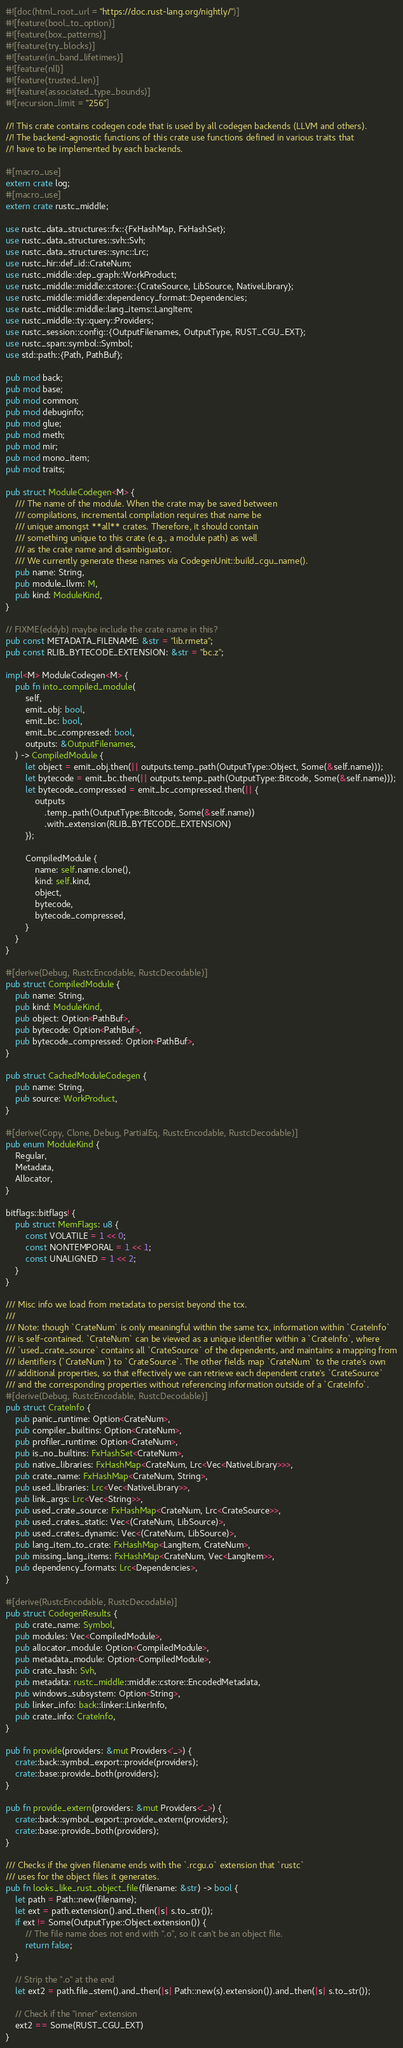Convert code to text. <code><loc_0><loc_0><loc_500><loc_500><_Rust_>#![doc(html_root_url = "https://doc.rust-lang.org/nightly/")]
#![feature(bool_to_option)]
#![feature(box_patterns)]
#![feature(try_blocks)]
#![feature(in_band_lifetimes)]
#![feature(nll)]
#![feature(trusted_len)]
#![feature(associated_type_bounds)]
#![recursion_limit = "256"]

//! This crate contains codegen code that is used by all codegen backends (LLVM and others).
//! The backend-agnostic functions of this crate use functions defined in various traits that
//! have to be implemented by each backends.

#[macro_use]
extern crate log;
#[macro_use]
extern crate rustc_middle;

use rustc_data_structures::fx::{FxHashMap, FxHashSet};
use rustc_data_structures::svh::Svh;
use rustc_data_structures::sync::Lrc;
use rustc_hir::def_id::CrateNum;
use rustc_middle::dep_graph::WorkProduct;
use rustc_middle::middle::cstore::{CrateSource, LibSource, NativeLibrary};
use rustc_middle::middle::dependency_format::Dependencies;
use rustc_middle::middle::lang_items::LangItem;
use rustc_middle::ty::query::Providers;
use rustc_session::config::{OutputFilenames, OutputType, RUST_CGU_EXT};
use rustc_span::symbol::Symbol;
use std::path::{Path, PathBuf};

pub mod back;
pub mod base;
pub mod common;
pub mod debuginfo;
pub mod glue;
pub mod meth;
pub mod mir;
pub mod mono_item;
pub mod traits;

pub struct ModuleCodegen<M> {
    /// The name of the module. When the crate may be saved between
    /// compilations, incremental compilation requires that name be
    /// unique amongst **all** crates. Therefore, it should contain
    /// something unique to this crate (e.g., a module path) as well
    /// as the crate name and disambiguator.
    /// We currently generate these names via CodegenUnit::build_cgu_name().
    pub name: String,
    pub module_llvm: M,
    pub kind: ModuleKind,
}

// FIXME(eddyb) maybe include the crate name in this?
pub const METADATA_FILENAME: &str = "lib.rmeta";
pub const RLIB_BYTECODE_EXTENSION: &str = "bc.z";

impl<M> ModuleCodegen<M> {
    pub fn into_compiled_module(
        self,
        emit_obj: bool,
        emit_bc: bool,
        emit_bc_compressed: bool,
        outputs: &OutputFilenames,
    ) -> CompiledModule {
        let object = emit_obj.then(|| outputs.temp_path(OutputType::Object, Some(&self.name)));
        let bytecode = emit_bc.then(|| outputs.temp_path(OutputType::Bitcode, Some(&self.name)));
        let bytecode_compressed = emit_bc_compressed.then(|| {
            outputs
                .temp_path(OutputType::Bitcode, Some(&self.name))
                .with_extension(RLIB_BYTECODE_EXTENSION)
        });

        CompiledModule {
            name: self.name.clone(),
            kind: self.kind,
            object,
            bytecode,
            bytecode_compressed,
        }
    }
}

#[derive(Debug, RustcEncodable, RustcDecodable)]
pub struct CompiledModule {
    pub name: String,
    pub kind: ModuleKind,
    pub object: Option<PathBuf>,
    pub bytecode: Option<PathBuf>,
    pub bytecode_compressed: Option<PathBuf>,
}

pub struct CachedModuleCodegen {
    pub name: String,
    pub source: WorkProduct,
}

#[derive(Copy, Clone, Debug, PartialEq, RustcEncodable, RustcDecodable)]
pub enum ModuleKind {
    Regular,
    Metadata,
    Allocator,
}

bitflags::bitflags! {
    pub struct MemFlags: u8 {
        const VOLATILE = 1 << 0;
        const NONTEMPORAL = 1 << 1;
        const UNALIGNED = 1 << 2;
    }
}

/// Misc info we load from metadata to persist beyond the tcx.
///
/// Note: though `CrateNum` is only meaningful within the same tcx, information within `CrateInfo`
/// is self-contained. `CrateNum` can be viewed as a unique identifier within a `CrateInfo`, where
/// `used_crate_source` contains all `CrateSource` of the dependents, and maintains a mapping from
/// identifiers (`CrateNum`) to `CrateSource`. The other fields map `CrateNum` to the crate's own
/// additional properties, so that effectively we can retrieve each dependent crate's `CrateSource`
/// and the corresponding properties without referencing information outside of a `CrateInfo`.
#[derive(Debug, RustcEncodable, RustcDecodable)]
pub struct CrateInfo {
    pub panic_runtime: Option<CrateNum>,
    pub compiler_builtins: Option<CrateNum>,
    pub profiler_runtime: Option<CrateNum>,
    pub is_no_builtins: FxHashSet<CrateNum>,
    pub native_libraries: FxHashMap<CrateNum, Lrc<Vec<NativeLibrary>>>,
    pub crate_name: FxHashMap<CrateNum, String>,
    pub used_libraries: Lrc<Vec<NativeLibrary>>,
    pub link_args: Lrc<Vec<String>>,
    pub used_crate_source: FxHashMap<CrateNum, Lrc<CrateSource>>,
    pub used_crates_static: Vec<(CrateNum, LibSource)>,
    pub used_crates_dynamic: Vec<(CrateNum, LibSource)>,
    pub lang_item_to_crate: FxHashMap<LangItem, CrateNum>,
    pub missing_lang_items: FxHashMap<CrateNum, Vec<LangItem>>,
    pub dependency_formats: Lrc<Dependencies>,
}

#[derive(RustcEncodable, RustcDecodable)]
pub struct CodegenResults {
    pub crate_name: Symbol,
    pub modules: Vec<CompiledModule>,
    pub allocator_module: Option<CompiledModule>,
    pub metadata_module: Option<CompiledModule>,
    pub crate_hash: Svh,
    pub metadata: rustc_middle::middle::cstore::EncodedMetadata,
    pub windows_subsystem: Option<String>,
    pub linker_info: back::linker::LinkerInfo,
    pub crate_info: CrateInfo,
}

pub fn provide(providers: &mut Providers<'_>) {
    crate::back::symbol_export::provide(providers);
    crate::base::provide_both(providers);
}

pub fn provide_extern(providers: &mut Providers<'_>) {
    crate::back::symbol_export::provide_extern(providers);
    crate::base::provide_both(providers);
}

/// Checks if the given filename ends with the `.rcgu.o` extension that `rustc`
/// uses for the object files it generates.
pub fn looks_like_rust_object_file(filename: &str) -> bool {
    let path = Path::new(filename);
    let ext = path.extension().and_then(|s| s.to_str());
    if ext != Some(OutputType::Object.extension()) {
        // The file name does not end with ".o", so it can't be an object file.
        return false;
    }

    // Strip the ".o" at the end
    let ext2 = path.file_stem().and_then(|s| Path::new(s).extension()).and_then(|s| s.to_str());

    // Check if the "inner" extension
    ext2 == Some(RUST_CGU_EXT)
}
</code> 